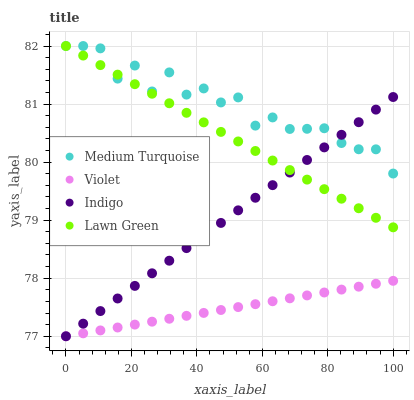Does Violet have the minimum area under the curve?
Answer yes or no. Yes. Does Medium Turquoise have the maximum area under the curve?
Answer yes or no. Yes. Does Indigo have the minimum area under the curve?
Answer yes or no. No. Does Indigo have the maximum area under the curve?
Answer yes or no. No. Is Violet the smoothest?
Answer yes or no. Yes. Is Medium Turquoise the roughest?
Answer yes or no. Yes. Is Indigo the smoothest?
Answer yes or no. No. Is Indigo the roughest?
Answer yes or no. No. Does Indigo have the lowest value?
Answer yes or no. Yes. Does Medium Turquoise have the lowest value?
Answer yes or no. No. Does Medium Turquoise have the highest value?
Answer yes or no. Yes. Does Indigo have the highest value?
Answer yes or no. No. Is Violet less than Lawn Green?
Answer yes or no. Yes. Is Lawn Green greater than Violet?
Answer yes or no. Yes. Does Lawn Green intersect Medium Turquoise?
Answer yes or no. Yes. Is Lawn Green less than Medium Turquoise?
Answer yes or no. No. Is Lawn Green greater than Medium Turquoise?
Answer yes or no. No. Does Violet intersect Lawn Green?
Answer yes or no. No. 